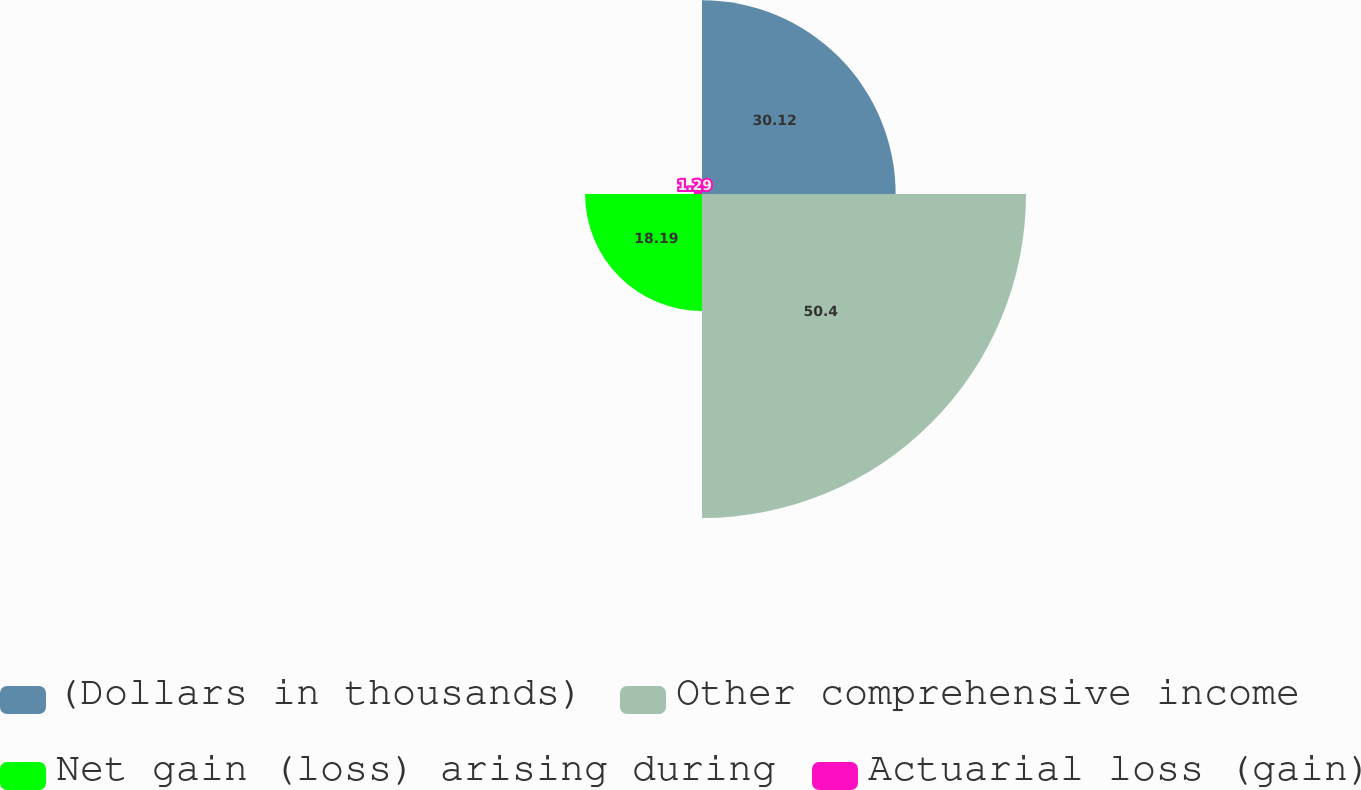Convert chart. <chart><loc_0><loc_0><loc_500><loc_500><pie_chart><fcel>(Dollars in thousands)<fcel>Other comprehensive income<fcel>Net gain (loss) arising during<fcel>Actuarial loss (gain)<nl><fcel>30.12%<fcel>50.4%<fcel>18.19%<fcel>1.29%<nl></chart> 